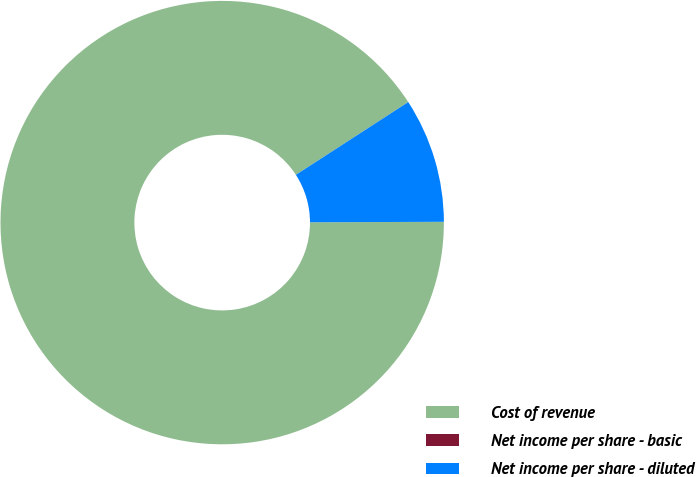Convert chart to OTSL. <chart><loc_0><loc_0><loc_500><loc_500><pie_chart><fcel>Cost of revenue<fcel>Net income per share - basic<fcel>Net income per share - diluted<nl><fcel>90.91%<fcel>0.0%<fcel>9.09%<nl></chart> 